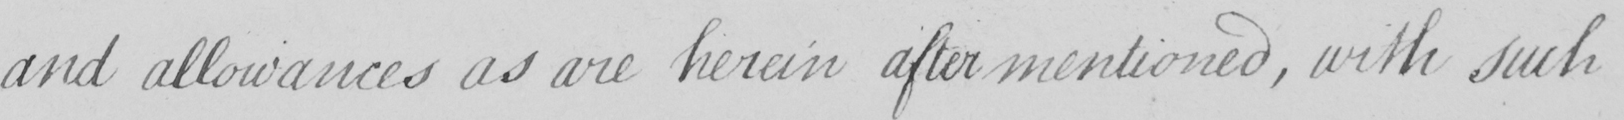Please transcribe the handwritten text in this image. and allowances as are herein after mentioned , with such 